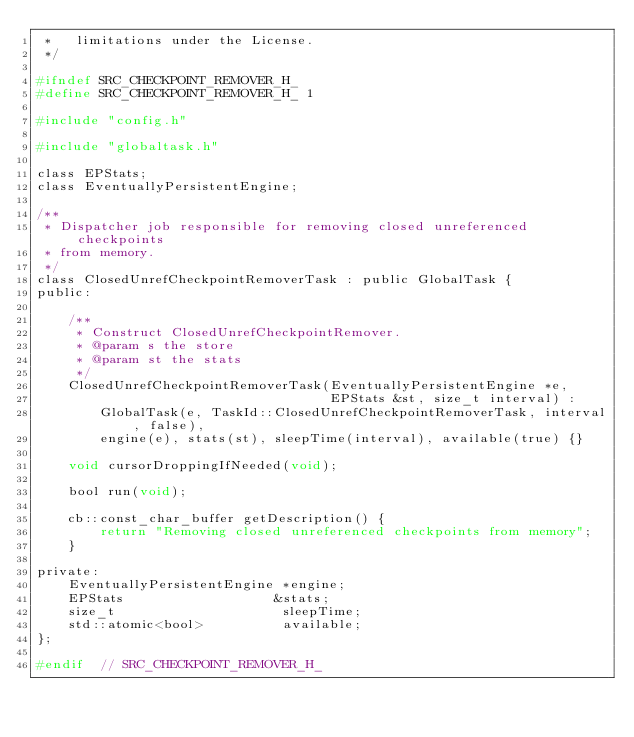<code> <loc_0><loc_0><loc_500><loc_500><_C_> *   limitations under the License.
 */

#ifndef SRC_CHECKPOINT_REMOVER_H_
#define SRC_CHECKPOINT_REMOVER_H_ 1

#include "config.h"

#include "globaltask.h"

class EPStats;
class EventuallyPersistentEngine;

/**
 * Dispatcher job responsible for removing closed unreferenced checkpoints
 * from memory.
 */
class ClosedUnrefCheckpointRemoverTask : public GlobalTask {
public:

    /**
     * Construct ClosedUnrefCheckpointRemover.
     * @param s the store
     * @param st the stats
     */
    ClosedUnrefCheckpointRemoverTask(EventuallyPersistentEngine *e,
                                     EPStats &st, size_t interval) :
        GlobalTask(e, TaskId::ClosedUnrefCheckpointRemoverTask, interval, false),
        engine(e), stats(st), sleepTime(interval), available(true) {}

    void cursorDroppingIfNeeded(void);

    bool run(void);

    cb::const_char_buffer getDescription() {
        return "Removing closed unreferenced checkpoints from memory";
    }

private:
    EventuallyPersistentEngine *engine;
    EPStats                   &stats;
    size_t                     sleepTime;
    std::atomic<bool>          available;
};

#endif  // SRC_CHECKPOINT_REMOVER_H_
</code> 